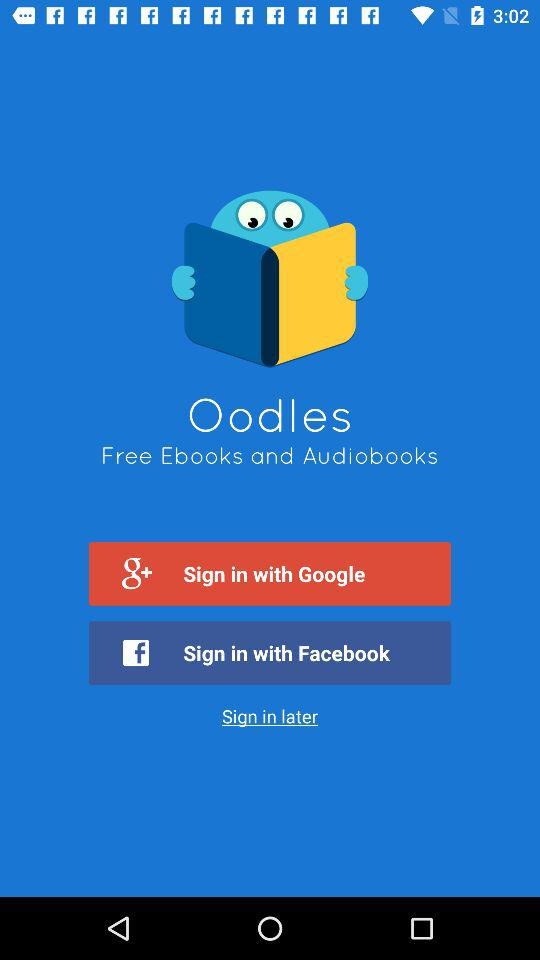Which application can we use to log in instead of "Google"? You can use "Facebook" to log in instead of "Google". 